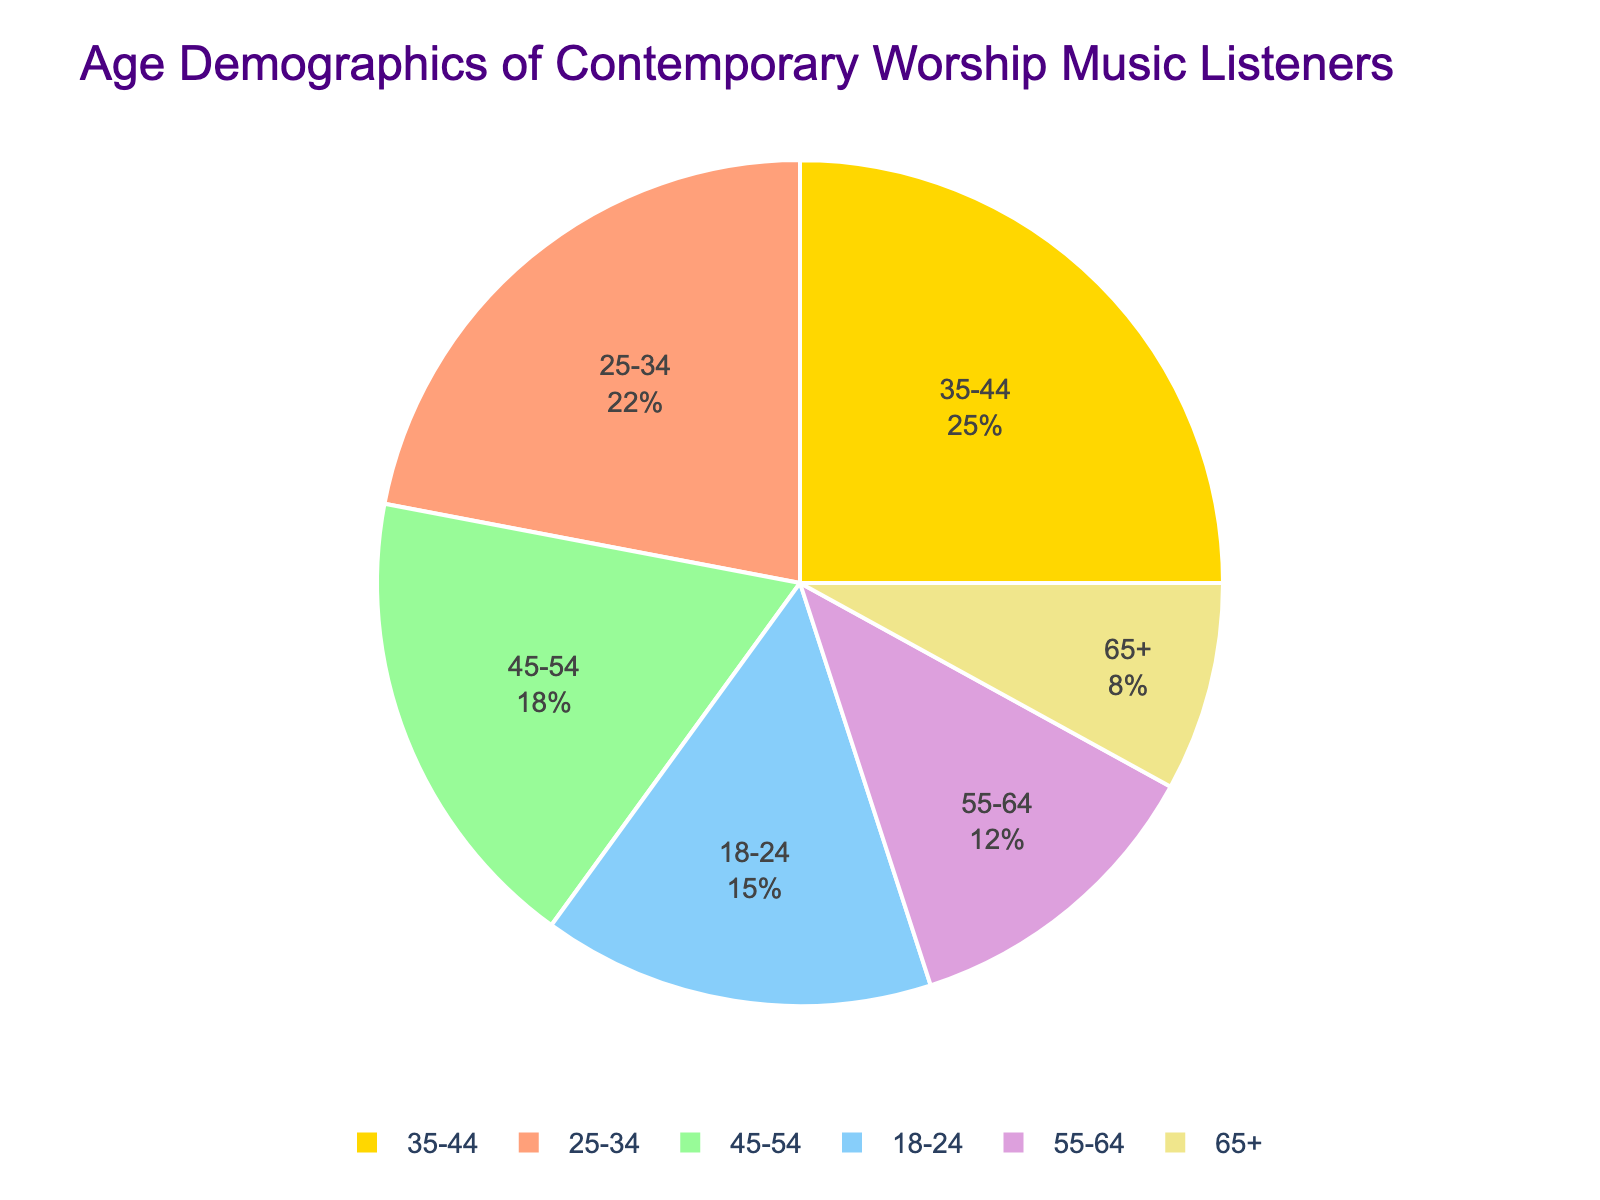What's the largest age group of contemporary worship music listeners? The figure shows that the age group with the highest percentage is 35-44 years. By looking at the actual percentage values, we can confirm that 25% represents the largest share.
Answer: 35-44 years Which age group has the smallest percentage of listeners? By observing the pie chart, the segment with the smallest area represents the 65+ age group. The percentage shown for this group is 8%, which is the smallest.
Answer: 65+ years How do the percentages of the 18-24 and 55-64 age groups compare? From the figure, the 18-24 age group has a percentage of 15% while the 55-64 age group has a percentage of 12%. 15% is greater than 12%, so the 18-24 age group has a higher percentage.
Answer: 18-24 has a higher percentage What is the combined percentage of listeners aged 35-44 and 45-54? From the pie chart, the percentages for the 35-44 and 45-54 age groups are 25% and 18%, respectively. Summing these values gives 25% + 18% = 43%.
Answer: 43% Which color represents the 25-34 age group? By visually inspecting the pie chart, the 25-34 age group is represented by the segment colored in a shade of light orange. This color distinguishes it from the other segments.
Answer: Light orange If you sum the percentages of listeners aged 25-34, 35-44, and 45-54, what do you get? The figure shows that the percentages for the 25-34, 35-44, and 45-54 age groups are 22%, 25%, and 18%, respectively. Summing these values gives 22% + 25% + 18% = 65%.
Answer: 65% Which two age groups combined form the second-largest share of listeners? Observing the chart, the largest age group is 35-44 with 25%. The next largest group is 25-34 with 22%. Combining these, the total is 25% + 22% = 47%, which is the second-largest after the single 35-44 group.
Answer: 25-34 and 35-44 What percentage of listeners are below 35 years old? The figure shows that the 18-24 age group has 15% and the 25-34 age group has 22%. Summing these gives 15% + 22% = 37%.
Answer: 37% Which age group has a 12% share, and what color represents it? From the pie chart, the 55-64 age group has a 12% share. The segment representing this group is colored in a shade of pale yellow.
Answer: 55-64, pale yellow 